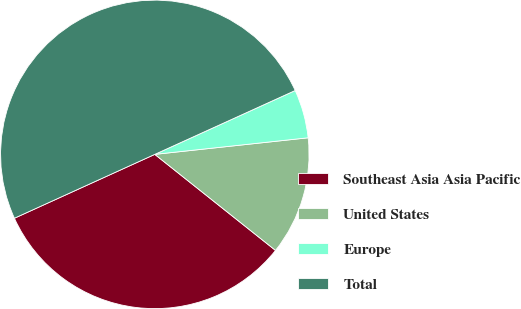<chart> <loc_0><loc_0><loc_500><loc_500><pie_chart><fcel>Southeast Asia Asia Pacific<fcel>United States<fcel>Europe<fcel>Total<nl><fcel>32.51%<fcel>12.41%<fcel>5.08%<fcel>50.0%<nl></chart> 